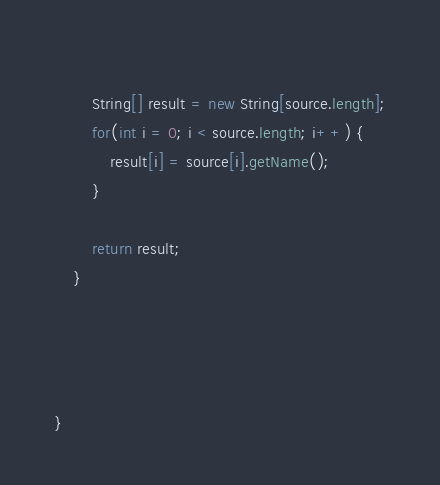<code> <loc_0><loc_0><loc_500><loc_500><_Java_>		
		String[] result = new String[source.length];
		for(int i = 0; i < source.length; i++) {
			result[i] = source[i].getName();
		}
		
		return result;
	}

	
	

}
</code> 